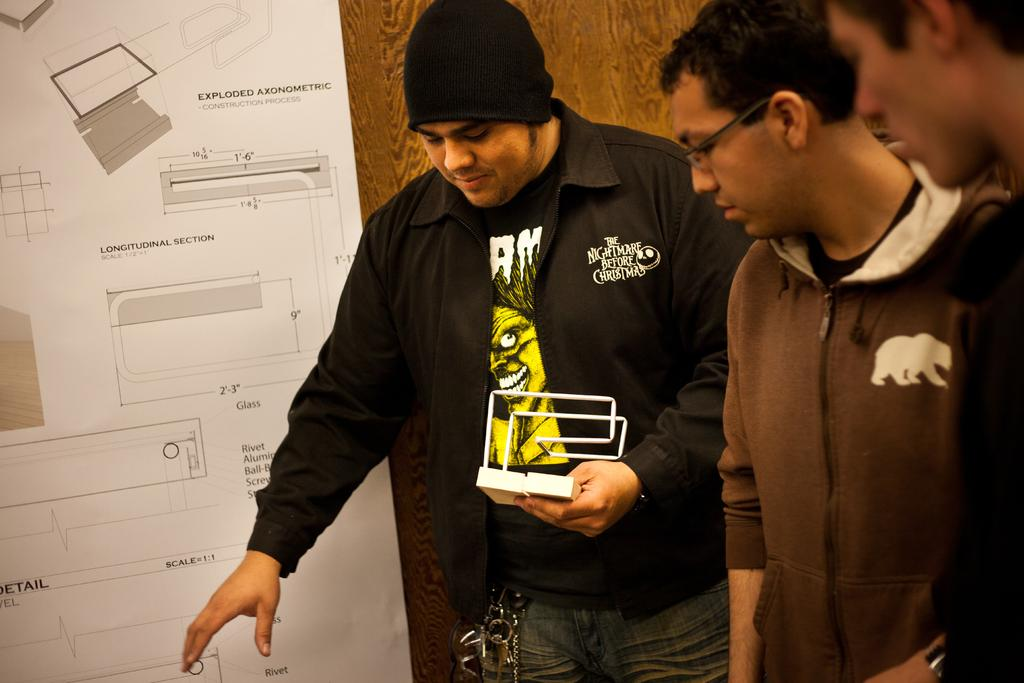How many people are in the image? There are three persons standing in the image. What is one of the persons doing in the image? There is a person holding an object in the image. Can you describe the background of the image? There is a paper stick to a wooden wall in the background of the image. What type of beast can be seen roaming around in the image? There is no beast present in the image. What flavor of rock is visible in the image? There is no rock present in the image, and therefore no flavor can be determined. 